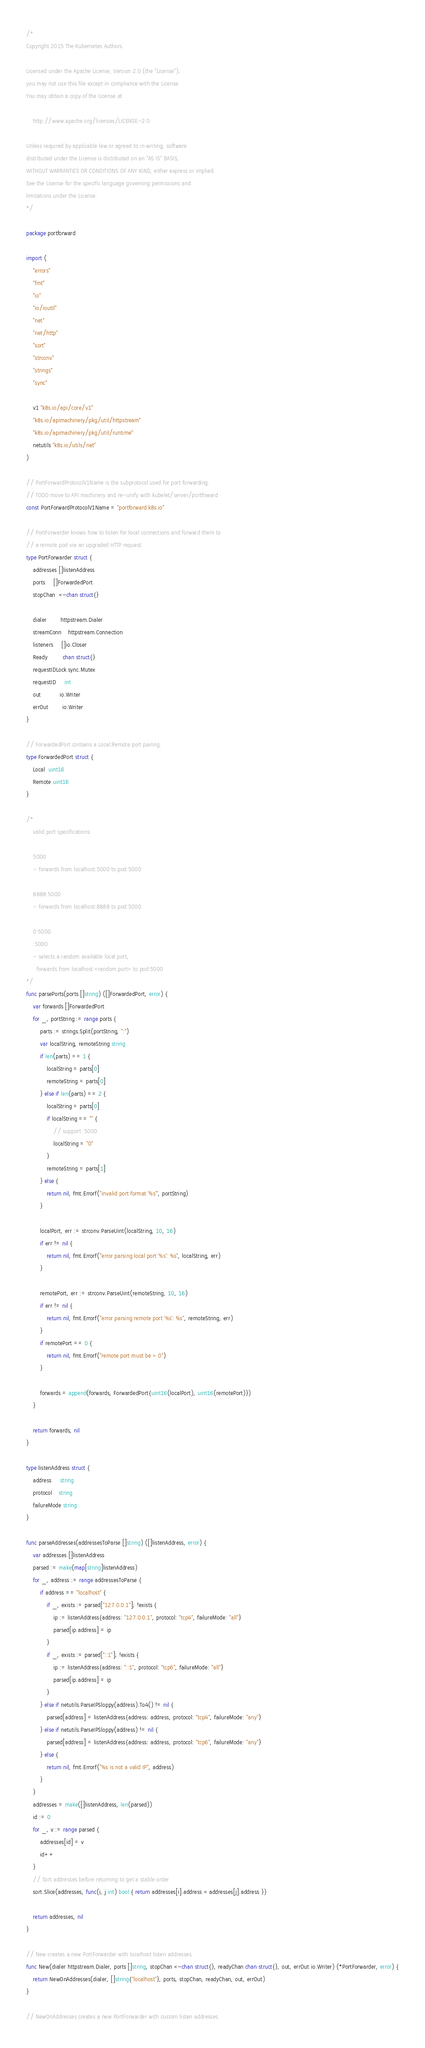Convert code to text. <code><loc_0><loc_0><loc_500><loc_500><_Go_>/*
Copyright 2015 The Kubernetes Authors.

Licensed under the Apache License, Version 2.0 (the "License");
you may not use this file except in compliance with the License.
You may obtain a copy of the License at

    http://www.apache.org/licenses/LICENSE-2.0

Unless required by applicable law or agreed to in writing, software
distributed under the License is distributed on an "AS IS" BASIS,
WITHOUT WARRANTIES OR CONDITIONS OF ANY KIND, either express or implied.
See the License for the specific language governing permissions and
limitations under the License.
*/

package portforward

import (
	"errors"
	"fmt"
	"io"
	"io/ioutil"
	"net"
	"net/http"
	"sort"
	"strconv"
	"strings"
	"sync"

	v1 "k8s.io/api/core/v1"
	"k8s.io/apimachinery/pkg/util/httpstream"
	"k8s.io/apimachinery/pkg/util/runtime"
	netutils "k8s.io/utils/net"
)

// PortForwardProtocolV1Name is the subprotocol used for port forwarding.
// TODO move to API machinery and re-unify with kubelet/server/portfoward
const PortForwardProtocolV1Name = "portforward.k8s.io"

// PortForwarder knows how to listen for local connections and forward them to
// a remote pod via an upgraded HTTP request.
type PortForwarder struct {
	addresses []listenAddress
	ports     []ForwardedPort
	stopChan  <-chan struct{}

	dialer        httpstream.Dialer
	streamConn    httpstream.Connection
	listeners     []io.Closer
	Ready         chan struct{}
	requestIDLock sync.Mutex
	requestID     int
	out           io.Writer
	errOut        io.Writer
}

// ForwardedPort contains a Local:Remote port pairing.
type ForwardedPort struct {
	Local  uint16
	Remote uint16
}

/*
	valid port specifications:

	5000
	- forwards from localhost:5000 to pod:5000

	8888:5000
	- forwards from localhost:8888 to pod:5000

	0:5000
	:5000
	- selects a random available local port,
	  forwards from localhost:<random port> to pod:5000
*/
func parsePorts(ports []string) ([]ForwardedPort, error) {
	var forwards []ForwardedPort
	for _, portString := range ports {
		parts := strings.Split(portString, ":")
		var localString, remoteString string
		if len(parts) == 1 {
			localString = parts[0]
			remoteString = parts[0]
		} else if len(parts) == 2 {
			localString = parts[0]
			if localString == "" {
				// support :5000
				localString = "0"
			}
			remoteString = parts[1]
		} else {
			return nil, fmt.Errorf("invalid port format '%s'", portString)
		}

		localPort, err := strconv.ParseUint(localString, 10, 16)
		if err != nil {
			return nil, fmt.Errorf("error parsing local port '%s': %s", localString, err)
		}

		remotePort, err := strconv.ParseUint(remoteString, 10, 16)
		if err != nil {
			return nil, fmt.Errorf("error parsing remote port '%s': %s", remoteString, err)
		}
		if remotePort == 0 {
			return nil, fmt.Errorf("remote port must be > 0")
		}

		forwards = append(forwards, ForwardedPort{uint16(localPort), uint16(remotePort)})
	}

	return forwards, nil
}

type listenAddress struct {
	address     string
	protocol    string
	failureMode string
}

func parseAddresses(addressesToParse []string) ([]listenAddress, error) {
	var addresses []listenAddress
	parsed := make(map[string]listenAddress)
	for _, address := range addressesToParse {
		if address == "localhost" {
			if _, exists := parsed["127.0.0.1"]; !exists {
				ip := listenAddress{address: "127.0.0.1", protocol: "tcp4", failureMode: "all"}
				parsed[ip.address] = ip
			}
			if _, exists := parsed["::1"]; !exists {
				ip := listenAddress{address: "::1", protocol: "tcp6", failureMode: "all"}
				parsed[ip.address] = ip
			}
		} else if netutils.ParseIPSloppy(address).To4() != nil {
			parsed[address] = listenAddress{address: address, protocol: "tcp4", failureMode: "any"}
		} else if netutils.ParseIPSloppy(address) != nil {
			parsed[address] = listenAddress{address: address, protocol: "tcp6", failureMode: "any"}
		} else {
			return nil, fmt.Errorf("%s is not a valid IP", address)
		}
	}
	addresses = make([]listenAddress, len(parsed))
	id := 0
	for _, v := range parsed {
		addresses[id] = v
		id++
	}
	// Sort addresses before returning to get a stable order
	sort.Slice(addresses, func(i, j int) bool { return addresses[i].address < addresses[j].address })

	return addresses, nil
}

// New creates a new PortForwarder with localhost listen addresses.
func New(dialer httpstream.Dialer, ports []string, stopChan <-chan struct{}, readyChan chan struct{}, out, errOut io.Writer) (*PortForwarder, error) {
	return NewOnAddresses(dialer, []string{"localhost"}, ports, stopChan, readyChan, out, errOut)
}

// NewOnAddresses creates a new PortForwarder with custom listen addresses.</code> 